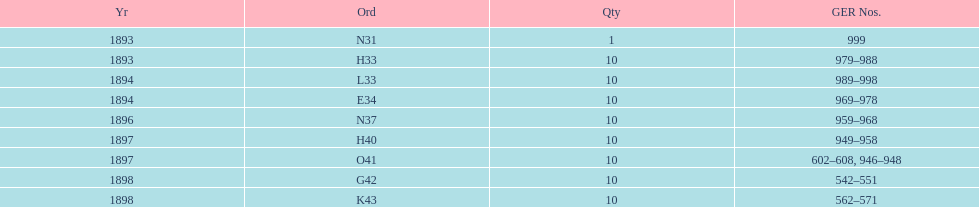Which year between 1893 and 1898 was there not an order? 1895. 